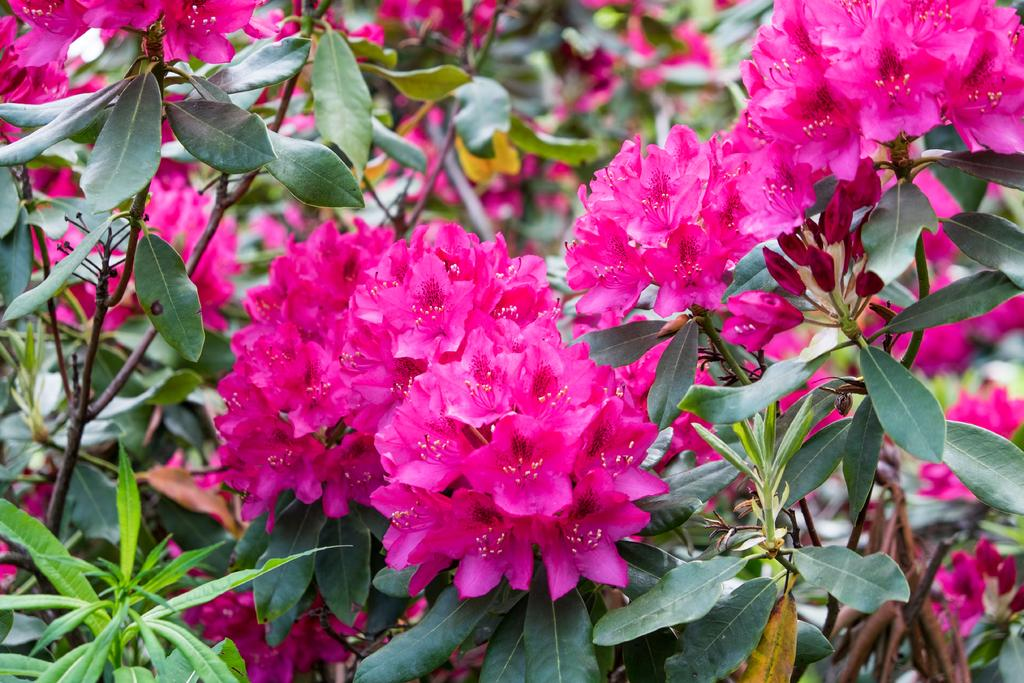Where was the image taken? The image was taken outdoors. What type of vegetation can be seen in the image? There are plants with leaves and stems in the image. What is the most prominent feature of the plants in the image? There are many flowers in the image. What is the color of the flowers in the image? The flowers are dark pink in color. Can you hear the bells ringing in the image? There are no bells present in the image, so it is not possible to hear them ringing. 